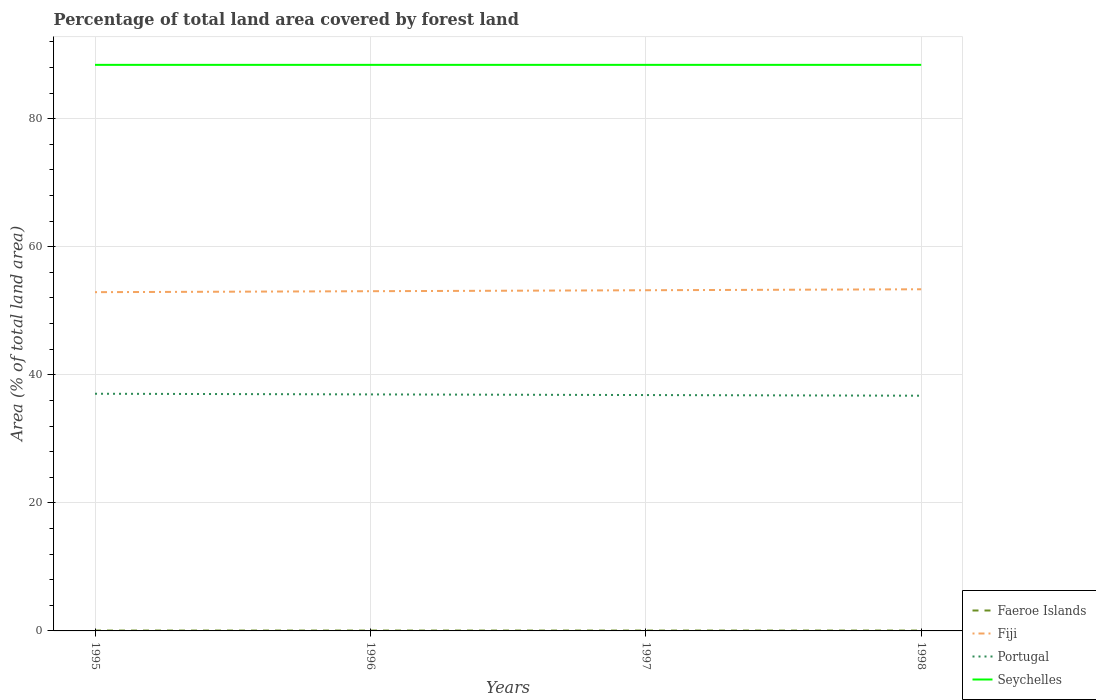Is the number of lines equal to the number of legend labels?
Provide a short and direct response. Yes. Across all years, what is the maximum percentage of forest land in Seychelles?
Offer a very short reply. 88.41. What is the difference between the highest and the second highest percentage of forest land in Portugal?
Give a very brief answer. 0.3. What is the difference between the highest and the lowest percentage of forest land in Faeroe Islands?
Ensure brevity in your answer.  0. What is the difference between two consecutive major ticks on the Y-axis?
Provide a succinct answer. 20. Are the values on the major ticks of Y-axis written in scientific E-notation?
Ensure brevity in your answer.  No. Where does the legend appear in the graph?
Give a very brief answer. Bottom right. How many legend labels are there?
Offer a very short reply. 4. How are the legend labels stacked?
Your answer should be compact. Vertical. What is the title of the graph?
Your response must be concise. Percentage of total land area covered by forest land. Does "Micronesia" appear as one of the legend labels in the graph?
Make the answer very short. No. What is the label or title of the Y-axis?
Offer a terse response. Area (% of total land area). What is the Area (% of total land area) of Faeroe Islands in 1995?
Offer a terse response. 0.06. What is the Area (% of total land area) in Fiji in 1995?
Give a very brief answer. 52.91. What is the Area (% of total land area) of Portugal in 1995?
Give a very brief answer. 37.04. What is the Area (% of total land area) of Seychelles in 1995?
Ensure brevity in your answer.  88.41. What is the Area (% of total land area) in Faeroe Islands in 1996?
Offer a terse response. 0.06. What is the Area (% of total land area) of Fiji in 1996?
Make the answer very short. 53.06. What is the Area (% of total land area) in Portugal in 1996?
Your answer should be compact. 36.94. What is the Area (% of total land area) of Seychelles in 1996?
Your answer should be compact. 88.41. What is the Area (% of total land area) in Faeroe Islands in 1997?
Offer a very short reply. 0.06. What is the Area (% of total land area) in Fiji in 1997?
Offer a very short reply. 53.21. What is the Area (% of total land area) in Portugal in 1997?
Offer a terse response. 36.84. What is the Area (% of total land area) in Seychelles in 1997?
Your response must be concise. 88.41. What is the Area (% of total land area) in Faeroe Islands in 1998?
Your answer should be very brief. 0.06. What is the Area (% of total land area) in Fiji in 1998?
Offer a terse response. 53.36. What is the Area (% of total land area) of Portugal in 1998?
Offer a very short reply. 36.74. What is the Area (% of total land area) of Seychelles in 1998?
Offer a very short reply. 88.41. Across all years, what is the maximum Area (% of total land area) in Faeroe Islands?
Give a very brief answer. 0.06. Across all years, what is the maximum Area (% of total land area) of Fiji?
Your response must be concise. 53.36. Across all years, what is the maximum Area (% of total land area) of Portugal?
Your answer should be very brief. 37.04. Across all years, what is the maximum Area (% of total land area) of Seychelles?
Offer a very short reply. 88.41. Across all years, what is the minimum Area (% of total land area) of Faeroe Islands?
Offer a very short reply. 0.06. Across all years, what is the minimum Area (% of total land area) of Fiji?
Offer a terse response. 52.91. Across all years, what is the minimum Area (% of total land area) of Portugal?
Offer a very short reply. 36.74. Across all years, what is the minimum Area (% of total land area) in Seychelles?
Keep it short and to the point. 88.41. What is the total Area (% of total land area) of Faeroe Islands in the graph?
Offer a very short reply. 0.23. What is the total Area (% of total land area) in Fiji in the graph?
Ensure brevity in your answer.  212.55. What is the total Area (% of total land area) of Portugal in the graph?
Offer a terse response. 147.56. What is the total Area (% of total land area) in Seychelles in the graph?
Your answer should be very brief. 353.65. What is the difference between the Area (% of total land area) of Faeroe Islands in 1995 and that in 1996?
Provide a succinct answer. 0. What is the difference between the Area (% of total land area) in Fiji in 1995 and that in 1996?
Give a very brief answer. -0.15. What is the difference between the Area (% of total land area) of Portugal in 1995 and that in 1996?
Keep it short and to the point. 0.1. What is the difference between the Area (% of total land area) of Seychelles in 1995 and that in 1996?
Give a very brief answer. 0. What is the difference between the Area (% of total land area) in Fiji in 1995 and that in 1997?
Provide a short and direct response. -0.3. What is the difference between the Area (% of total land area) of Portugal in 1995 and that in 1997?
Keep it short and to the point. 0.2. What is the difference between the Area (% of total land area) of Faeroe Islands in 1995 and that in 1998?
Offer a very short reply. 0. What is the difference between the Area (% of total land area) in Fiji in 1995 and that in 1998?
Your answer should be very brief. -0.45. What is the difference between the Area (% of total land area) of Portugal in 1995 and that in 1998?
Ensure brevity in your answer.  0.3. What is the difference between the Area (% of total land area) of Fiji in 1996 and that in 1997?
Give a very brief answer. -0.15. What is the difference between the Area (% of total land area) in Portugal in 1996 and that in 1997?
Your response must be concise. 0.1. What is the difference between the Area (% of total land area) of Fiji in 1996 and that in 1998?
Make the answer very short. -0.3. What is the difference between the Area (% of total land area) of Portugal in 1996 and that in 1998?
Offer a terse response. 0.2. What is the difference between the Area (% of total land area) in Seychelles in 1996 and that in 1998?
Provide a short and direct response. 0. What is the difference between the Area (% of total land area) in Faeroe Islands in 1997 and that in 1998?
Give a very brief answer. 0. What is the difference between the Area (% of total land area) in Fiji in 1997 and that in 1998?
Provide a succinct answer. -0.15. What is the difference between the Area (% of total land area) in Portugal in 1997 and that in 1998?
Your answer should be compact. 0.1. What is the difference between the Area (% of total land area) in Seychelles in 1997 and that in 1998?
Offer a very short reply. 0. What is the difference between the Area (% of total land area) of Faeroe Islands in 1995 and the Area (% of total land area) of Fiji in 1996?
Your answer should be compact. -53. What is the difference between the Area (% of total land area) of Faeroe Islands in 1995 and the Area (% of total land area) of Portugal in 1996?
Ensure brevity in your answer.  -36.88. What is the difference between the Area (% of total land area) of Faeroe Islands in 1995 and the Area (% of total land area) of Seychelles in 1996?
Keep it short and to the point. -88.36. What is the difference between the Area (% of total land area) in Fiji in 1995 and the Area (% of total land area) in Portugal in 1996?
Ensure brevity in your answer.  15.97. What is the difference between the Area (% of total land area) in Fiji in 1995 and the Area (% of total land area) in Seychelles in 1996?
Make the answer very short. -35.5. What is the difference between the Area (% of total land area) in Portugal in 1995 and the Area (% of total land area) in Seychelles in 1996?
Your response must be concise. -51.37. What is the difference between the Area (% of total land area) of Faeroe Islands in 1995 and the Area (% of total land area) of Fiji in 1997?
Keep it short and to the point. -53.15. What is the difference between the Area (% of total land area) in Faeroe Islands in 1995 and the Area (% of total land area) in Portugal in 1997?
Your response must be concise. -36.78. What is the difference between the Area (% of total land area) of Faeroe Islands in 1995 and the Area (% of total land area) of Seychelles in 1997?
Offer a terse response. -88.36. What is the difference between the Area (% of total land area) of Fiji in 1995 and the Area (% of total land area) of Portugal in 1997?
Offer a terse response. 16.07. What is the difference between the Area (% of total land area) of Fiji in 1995 and the Area (% of total land area) of Seychelles in 1997?
Give a very brief answer. -35.5. What is the difference between the Area (% of total land area) in Portugal in 1995 and the Area (% of total land area) in Seychelles in 1997?
Your response must be concise. -51.37. What is the difference between the Area (% of total land area) of Faeroe Islands in 1995 and the Area (% of total land area) of Fiji in 1998?
Your answer should be compact. -53.3. What is the difference between the Area (% of total land area) in Faeroe Islands in 1995 and the Area (% of total land area) in Portugal in 1998?
Offer a very short reply. -36.68. What is the difference between the Area (% of total land area) in Faeroe Islands in 1995 and the Area (% of total land area) in Seychelles in 1998?
Offer a very short reply. -88.36. What is the difference between the Area (% of total land area) in Fiji in 1995 and the Area (% of total land area) in Portugal in 1998?
Give a very brief answer. 16.17. What is the difference between the Area (% of total land area) in Fiji in 1995 and the Area (% of total land area) in Seychelles in 1998?
Keep it short and to the point. -35.5. What is the difference between the Area (% of total land area) of Portugal in 1995 and the Area (% of total land area) of Seychelles in 1998?
Provide a succinct answer. -51.37. What is the difference between the Area (% of total land area) of Faeroe Islands in 1996 and the Area (% of total land area) of Fiji in 1997?
Your answer should be very brief. -53.15. What is the difference between the Area (% of total land area) of Faeroe Islands in 1996 and the Area (% of total land area) of Portugal in 1997?
Offer a terse response. -36.78. What is the difference between the Area (% of total land area) in Faeroe Islands in 1996 and the Area (% of total land area) in Seychelles in 1997?
Ensure brevity in your answer.  -88.36. What is the difference between the Area (% of total land area) of Fiji in 1996 and the Area (% of total land area) of Portugal in 1997?
Ensure brevity in your answer.  16.22. What is the difference between the Area (% of total land area) of Fiji in 1996 and the Area (% of total land area) of Seychelles in 1997?
Your response must be concise. -35.35. What is the difference between the Area (% of total land area) in Portugal in 1996 and the Area (% of total land area) in Seychelles in 1997?
Ensure brevity in your answer.  -51.47. What is the difference between the Area (% of total land area) in Faeroe Islands in 1996 and the Area (% of total land area) in Fiji in 1998?
Your answer should be compact. -53.3. What is the difference between the Area (% of total land area) of Faeroe Islands in 1996 and the Area (% of total land area) of Portugal in 1998?
Your answer should be compact. -36.68. What is the difference between the Area (% of total land area) in Faeroe Islands in 1996 and the Area (% of total land area) in Seychelles in 1998?
Keep it short and to the point. -88.36. What is the difference between the Area (% of total land area) in Fiji in 1996 and the Area (% of total land area) in Portugal in 1998?
Your answer should be compact. 16.32. What is the difference between the Area (% of total land area) in Fiji in 1996 and the Area (% of total land area) in Seychelles in 1998?
Offer a terse response. -35.35. What is the difference between the Area (% of total land area) of Portugal in 1996 and the Area (% of total land area) of Seychelles in 1998?
Keep it short and to the point. -51.47. What is the difference between the Area (% of total land area) in Faeroe Islands in 1997 and the Area (% of total land area) in Fiji in 1998?
Offer a very short reply. -53.3. What is the difference between the Area (% of total land area) of Faeroe Islands in 1997 and the Area (% of total land area) of Portugal in 1998?
Offer a very short reply. -36.68. What is the difference between the Area (% of total land area) of Faeroe Islands in 1997 and the Area (% of total land area) of Seychelles in 1998?
Keep it short and to the point. -88.36. What is the difference between the Area (% of total land area) in Fiji in 1997 and the Area (% of total land area) in Portugal in 1998?
Give a very brief answer. 16.47. What is the difference between the Area (% of total land area) of Fiji in 1997 and the Area (% of total land area) of Seychelles in 1998?
Your answer should be very brief. -35.2. What is the difference between the Area (% of total land area) in Portugal in 1997 and the Area (% of total land area) in Seychelles in 1998?
Your answer should be very brief. -51.57. What is the average Area (% of total land area) of Faeroe Islands per year?
Your answer should be compact. 0.06. What is the average Area (% of total land area) of Fiji per year?
Make the answer very short. 53.14. What is the average Area (% of total land area) in Portugal per year?
Provide a succinct answer. 36.89. What is the average Area (% of total land area) of Seychelles per year?
Your answer should be very brief. 88.41. In the year 1995, what is the difference between the Area (% of total land area) of Faeroe Islands and Area (% of total land area) of Fiji?
Provide a short and direct response. -52.85. In the year 1995, what is the difference between the Area (% of total land area) of Faeroe Islands and Area (% of total land area) of Portugal?
Provide a succinct answer. -36.99. In the year 1995, what is the difference between the Area (% of total land area) of Faeroe Islands and Area (% of total land area) of Seychelles?
Keep it short and to the point. -88.36. In the year 1995, what is the difference between the Area (% of total land area) in Fiji and Area (% of total land area) in Portugal?
Give a very brief answer. 15.87. In the year 1995, what is the difference between the Area (% of total land area) in Fiji and Area (% of total land area) in Seychelles?
Provide a short and direct response. -35.5. In the year 1995, what is the difference between the Area (% of total land area) of Portugal and Area (% of total land area) of Seychelles?
Offer a terse response. -51.37. In the year 1996, what is the difference between the Area (% of total land area) of Faeroe Islands and Area (% of total land area) of Fiji?
Give a very brief answer. -53. In the year 1996, what is the difference between the Area (% of total land area) in Faeroe Islands and Area (% of total land area) in Portugal?
Offer a very short reply. -36.88. In the year 1996, what is the difference between the Area (% of total land area) of Faeroe Islands and Area (% of total land area) of Seychelles?
Your answer should be very brief. -88.36. In the year 1996, what is the difference between the Area (% of total land area) of Fiji and Area (% of total land area) of Portugal?
Make the answer very short. 16.12. In the year 1996, what is the difference between the Area (% of total land area) of Fiji and Area (% of total land area) of Seychelles?
Your response must be concise. -35.35. In the year 1996, what is the difference between the Area (% of total land area) in Portugal and Area (% of total land area) in Seychelles?
Your answer should be compact. -51.47. In the year 1997, what is the difference between the Area (% of total land area) of Faeroe Islands and Area (% of total land area) of Fiji?
Your answer should be compact. -53.15. In the year 1997, what is the difference between the Area (% of total land area) in Faeroe Islands and Area (% of total land area) in Portugal?
Offer a terse response. -36.78. In the year 1997, what is the difference between the Area (% of total land area) of Faeroe Islands and Area (% of total land area) of Seychelles?
Offer a very short reply. -88.36. In the year 1997, what is the difference between the Area (% of total land area) in Fiji and Area (% of total land area) in Portugal?
Offer a very short reply. 16.37. In the year 1997, what is the difference between the Area (% of total land area) of Fiji and Area (% of total land area) of Seychelles?
Offer a terse response. -35.2. In the year 1997, what is the difference between the Area (% of total land area) of Portugal and Area (% of total land area) of Seychelles?
Your answer should be compact. -51.57. In the year 1998, what is the difference between the Area (% of total land area) in Faeroe Islands and Area (% of total land area) in Fiji?
Your answer should be very brief. -53.3. In the year 1998, what is the difference between the Area (% of total land area) of Faeroe Islands and Area (% of total land area) of Portugal?
Give a very brief answer. -36.68. In the year 1998, what is the difference between the Area (% of total land area) of Faeroe Islands and Area (% of total land area) of Seychelles?
Your answer should be very brief. -88.36. In the year 1998, what is the difference between the Area (% of total land area) of Fiji and Area (% of total land area) of Portugal?
Provide a succinct answer. 16.62. In the year 1998, what is the difference between the Area (% of total land area) in Fiji and Area (% of total land area) in Seychelles?
Keep it short and to the point. -35.05. In the year 1998, what is the difference between the Area (% of total land area) in Portugal and Area (% of total land area) in Seychelles?
Ensure brevity in your answer.  -51.67. What is the ratio of the Area (% of total land area) in Portugal in 1995 to that in 1996?
Provide a short and direct response. 1. What is the ratio of the Area (% of total land area) in Seychelles in 1995 to that in 1996?
Keep it short and to the point. 1. What is the ratio of the Area (% of total land area) of Faeroe Islands in 1995 to that in 1997?
Your response must be concise. 1. What is the ratio of the Area (% of total land area) of Fiji in 1995 to that in 1997?
Provide a short and direct response. 0.99. What is the ratio of the Area (% of total land area) of Portugal in 1995 to that in 1997?
Your response must be concise. 1.01. What is the ratio of the Area (% of total land area) in Faeroe Islands in 1995 to that in 1998?
Make the answer very short. 1. What is the ratio of the Area (% of total land area) in Portugal in 1995 to that in 1998?
Offer a terse response. 1.01. What is the ratio of the Area (% of total land area) in Seychelles in 1995 to that in 1998?
Offer a very short reply. 1. What is the ratio of the Area (% of total land area) of Faeroe Islands in 1996 to that in 1997?
Give a very brief answer. 1. What is the ratio of the Area (% of total land area) in Fiji in 1996 to that in 1997?
Make the answer very short. 1. What is the ratio of the Area (% of total land area) of Faeroe Islands in 1996 to that in 1998?
Provide a succinct answer. 1. What is the ratio of the Area (% of total land area) of Seychelles in 1996 to that in 1998?
Make the answer very short. 1. What is the ratio of the Area (% of total land area) in Faeroe Islands in 1997 to that in 1998?
Ensure brevity in your answer.  1. What is the ratio of the Area (% of total land area) of Fiji in 1997 to that in 1998?
Your response must be concise. 1. What is the difference between the highest and the second highest Area (% of total land area) in Faeroe Islands?
Ensure brevity in your answer.  0. What is the difference between the highest and the second highest Area (% of total land area) of Fiji?
Provide a short and direct response. 0.15. What is the difference between the highest and the second highest Area (% of total land area) in Portugal?
Your answer should be very brief. 0.1. What is the difference between the highest and the lowest Area (% of total land area) of Fiji?
Provide a succinct answer. 0.45. What is the difference between the highest and the lowest Area (% of total land area) of Portugal?
Give a very brief answer. 0.3. 